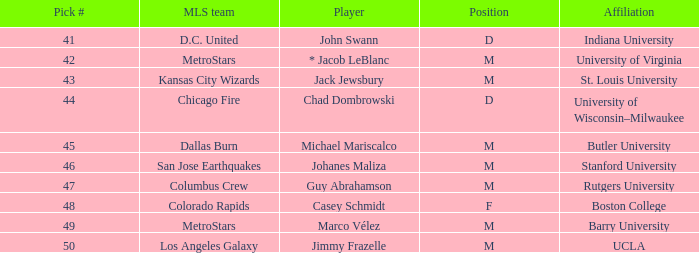What rank has ucla chosen that is greater than #47? M. 